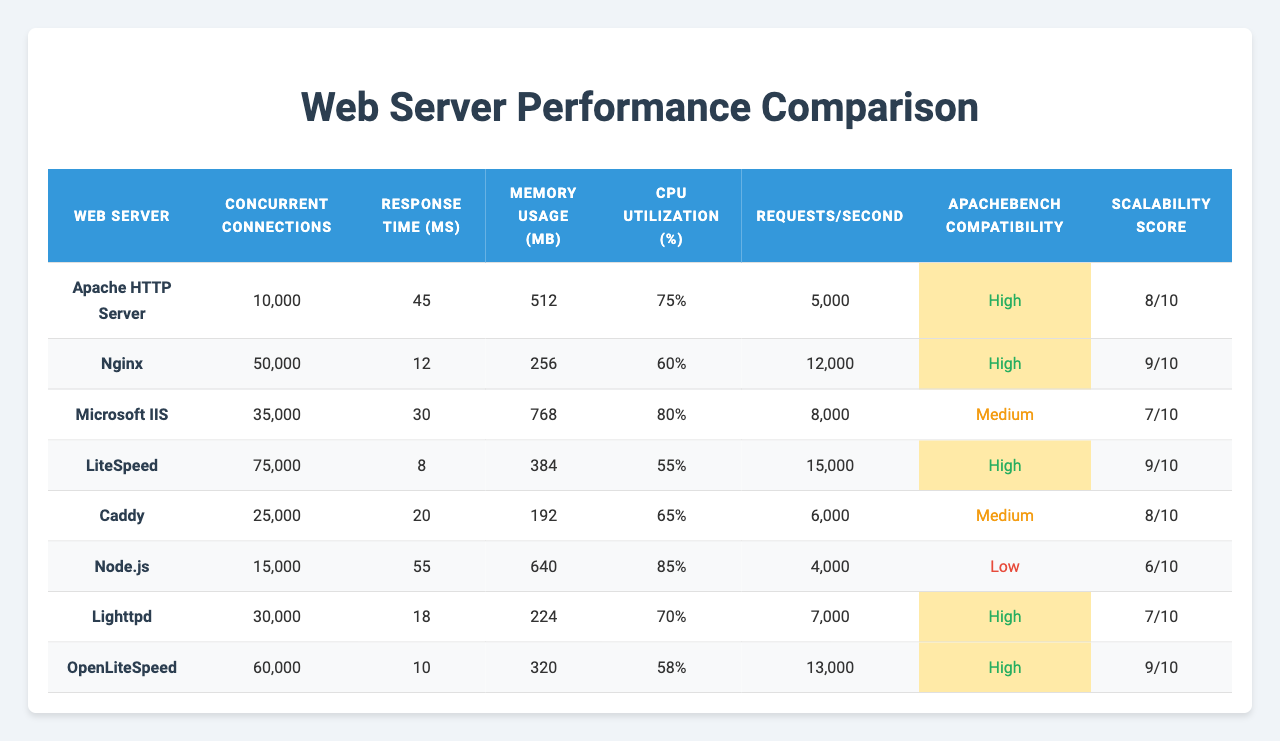What is the maximum number of concurrent connections handled by Nginx? The maximum number of concurrent connections for Nginx is listed in the table under "Concurrent Connections", which shows a value of 50,000.
Answer: 50,000 Which web server has the lowest response time? The response times are listed in milliseconds. Sorting through them reveals that LiteSpeed has the lowest response time at 8 ms.
Answer: 8 ms What is the average scalability score of the web servers presented? To find the average, sum the scalability scores (8 + 9 + 7 + 9 + 8 + 6 + 7 + 9) = 63 and divide by the number of servers (8): 63 / 8 = 7.875.
Answer: 7.875 Is the Apache HTTP Server more CPU intensive than Node.js? Comparing the CPU utilization percentages shows Apache at 75% and Node.js at 85%. Therefore, Node.js is more CPU intensive than Apache.
Answer: No How many more requests per second can LiteSpeed handle compared to Caddy? LiteSpeed's requests per second is 15,000 while Caddy's is 6,000. Subtracting these values gives 15,000 - 6,000 = 9,000 requests per second more.
Answer: 9,000 requests per second Which web server requires the most memory? The memory usage values are compared, and Microsoft IIS utilizes 768 MB, which is the highest among all the servers listed.
Answer: 768 MB Is there a server that offers high compatibility with ApacheBench and also has a scalability score of at least 8? Reviewing the table, Apache HTTP Server (high compatibility, score of 8), Nginx (high compatibility, score of 9), LiteSpeed (high compatibility, score of 9), and OpenLiteSpeed (high compatibility, score of 9) fit this criterion.
Answer: Yes What is the relationship between concurrent connections and memory usage for Node.js? Node.js handles 15,000 concurrent connections and uses 640 MB of memory. This indicates a lower capacity for memory relative to the number of connections compared to others like Nginx.
Answer: Higher connections, moderate memory usage How much CPU utilization does the LiteSpeed web server have compared to Microsoft IIS? LiteSpeed has 55% CPU utilization, and Microsoft IIS is at 80%. Thus, LiteSpeed is less CPU intensive than Microsoft IIS by 25%.
Answer: LiteSpeed is less CPU intensive Which web server has a higher scalability score, Apache HTTP Server or Lighttpd? Checking the scalability scores, Apache HTTP Server has a score of 8 while Lighttpd has a score of 7. Therefore, Apache HTTP Server has a higher score.
Answer: Apache HTTP Server 